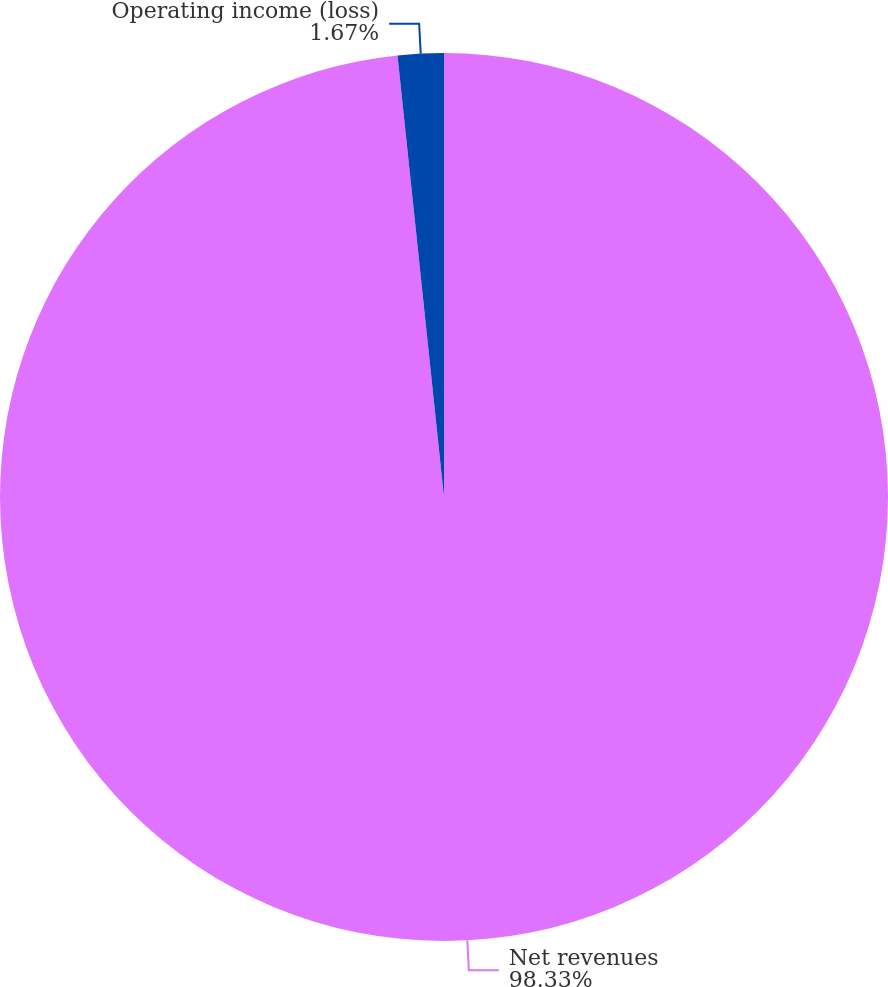<chart> <loc_0><loc_0><loc_500><loc_500><pie_chart><fcel>Net revenues<fcel>Operating income (loss)<nl><fcel>98.33%<fcel>1.67%<nl></chart> 